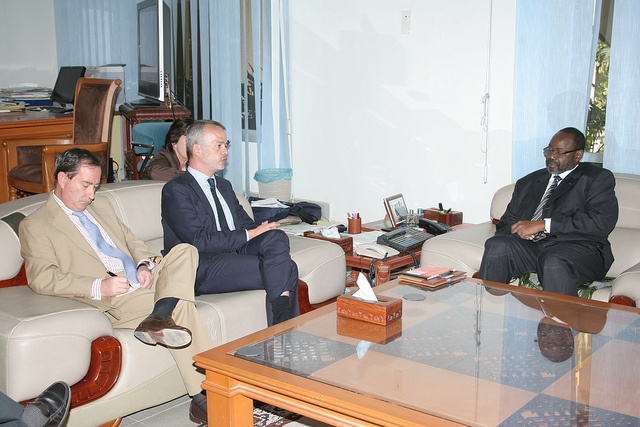Describe the objects in this image and their specific colors. I can see couch in darkgray and lightgray tones, people in darkgray, tan, and lightgray tones, people in darkgray, black, and gray tones, people in darkgray, gray, and black tones, and chair in darkgray, maroon, brown, and black tones in this image. 